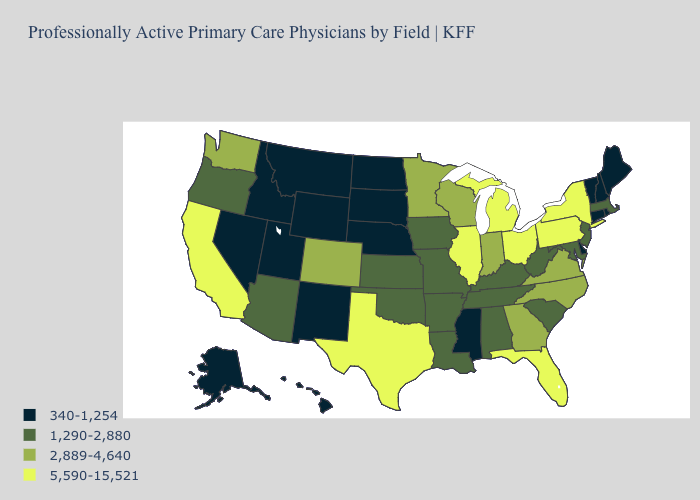What is the value of Oklahoma?
Short answer required. 1,290-2,880. Name the states that have a value in the range 1,290-2,880?
Short answer required. Alabama, Arizona, Arkansas, Iowa, Kansas, Kentucky, Louisiana, Maryland, Massachusetts, Missouri, New Jersey, Oklahoma, Oregon, South Carolina, Tennessee, West Virginia. How many symbols are there in the legend?
Answer briefly. 4. What is the highest value in the West ?
Keep it brief. 5,590-15,521. Which states hav the highest value in the Northeast?
Give a very brief answer. New York, Pennsylvania. What is the value of Missouri?
Be succinct. 1,290-2,880. What is the value of Arizona?
Quick response, please. 1,290-2,880. What is the value of Hawaii?
Concise answer only. 340-1,254. Name the states that have a value in the range 340-1,254?
Answer briefly. Alaska, Connecticut, Delaware, Hawaii, Idaho, Maine, Mississippi, Montana, Nebraska, Nevada, New Hampshire, New Mexico, North Dakota, Rhode Island, South Dakota, Utah, Vermont, Wyoming. Among the states that border Nevada , does Arizona have the lowest value?
Concise answer only. No. Does Ohio have the lowest value in the USA?
Keep it brief. No. Does the first symbol in the legend represent the smallest category?
Concise answer only. Yes. Which states have the highest value in the USA?
Be succinct. California, Florida, Illinois, Michigan, New York, Ohio, Pennsylvania, Texas. What is the lowest value in the USA?
Quick response, please. 340-1,254. 